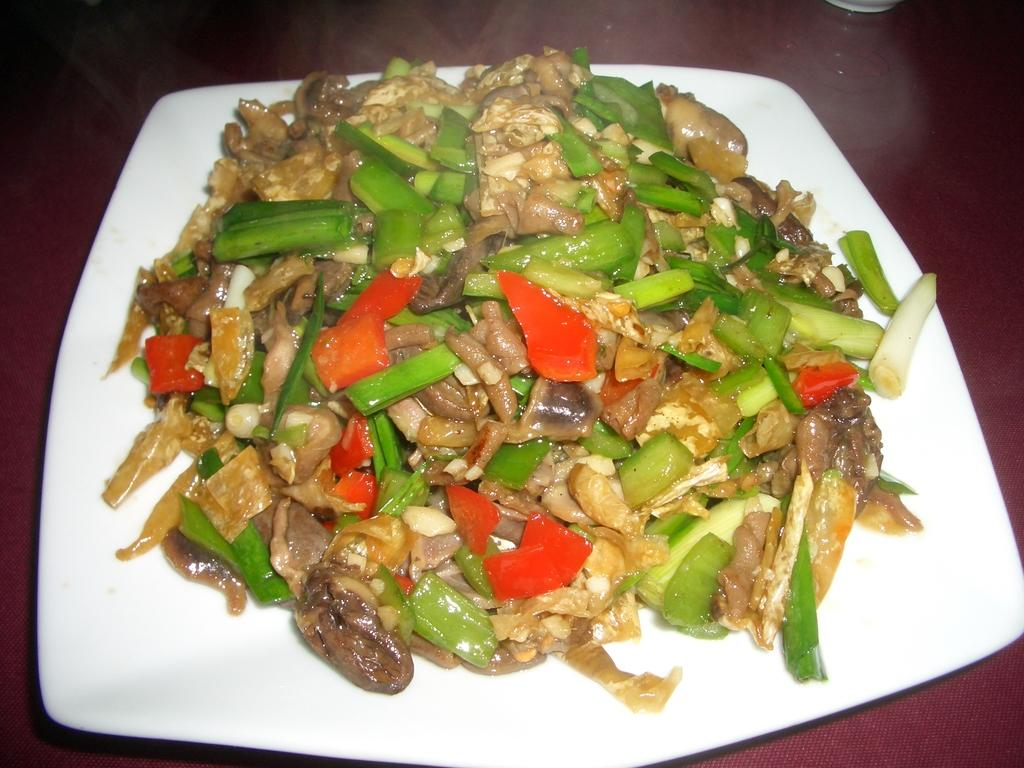What is on the plate that is visible in the image? There is food on a plate in the image. What color is the plate? The plate is white. What color is the surface on which the plate is placed? The plate is placed on a red surface. Can you tell me how many people are wearing boots in the image? There are no people or boots present in the image; it only features a plate of food on a red surface. 